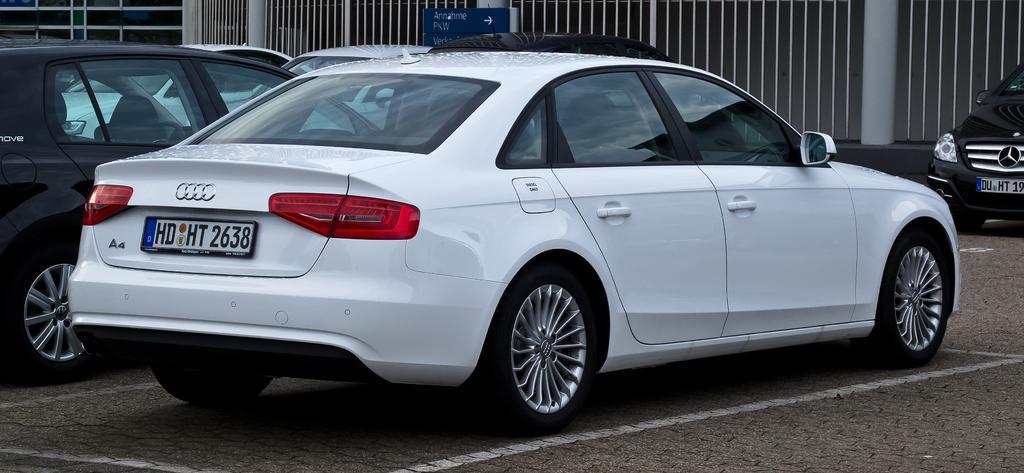Could you give a brief overview of what you see in this image? In this image, we can see some cars. There are grills at the top of the image. 